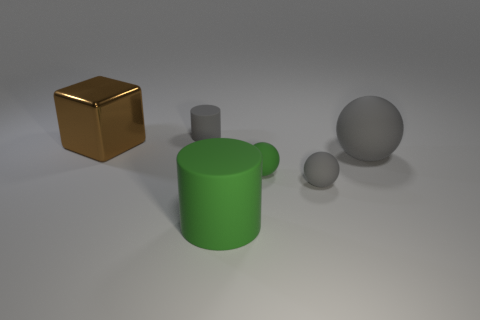How many tiny matte cylinders are in front of the brown shiny block? There are no tiny matte cylinders in front of the brown shiny block. The composition includes a shiny golden brown block and other items, such as a large matte cylinder, which may have prompted the question, but there are no tiny matte cylinders present. 